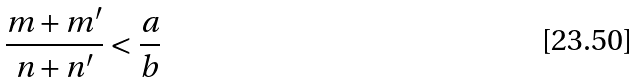<formula> <loc_0><loc_0><loc_500><loc_500>\frac { m + m ^ { \prime } } { n + n ^ { \prime } } < \frac { a } { b }</formula> 